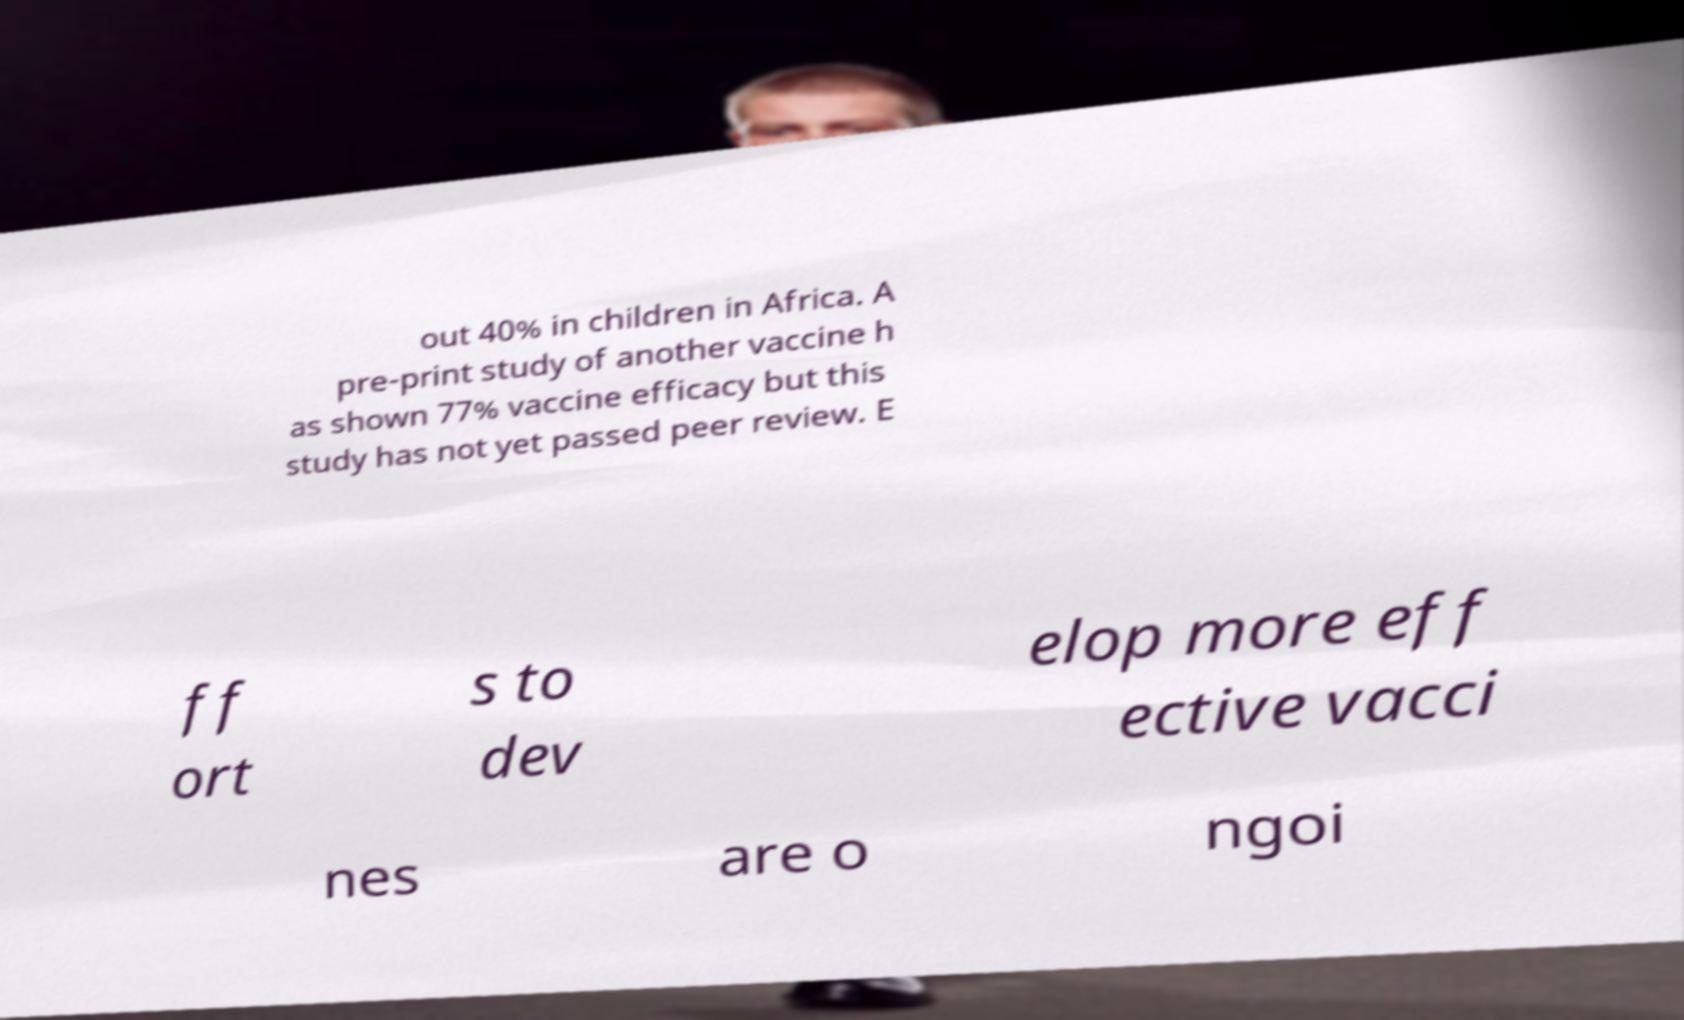For documentation purposes, I need the text within this image transcribed. Could you provide that? out 40% in children in Africa. A pre-print study of another vaccine h as shown 77% vaccine efficacy but this study has not yet passed peer review. E ff ort s to dev elop more eff ective vacci nes are o ngoi 